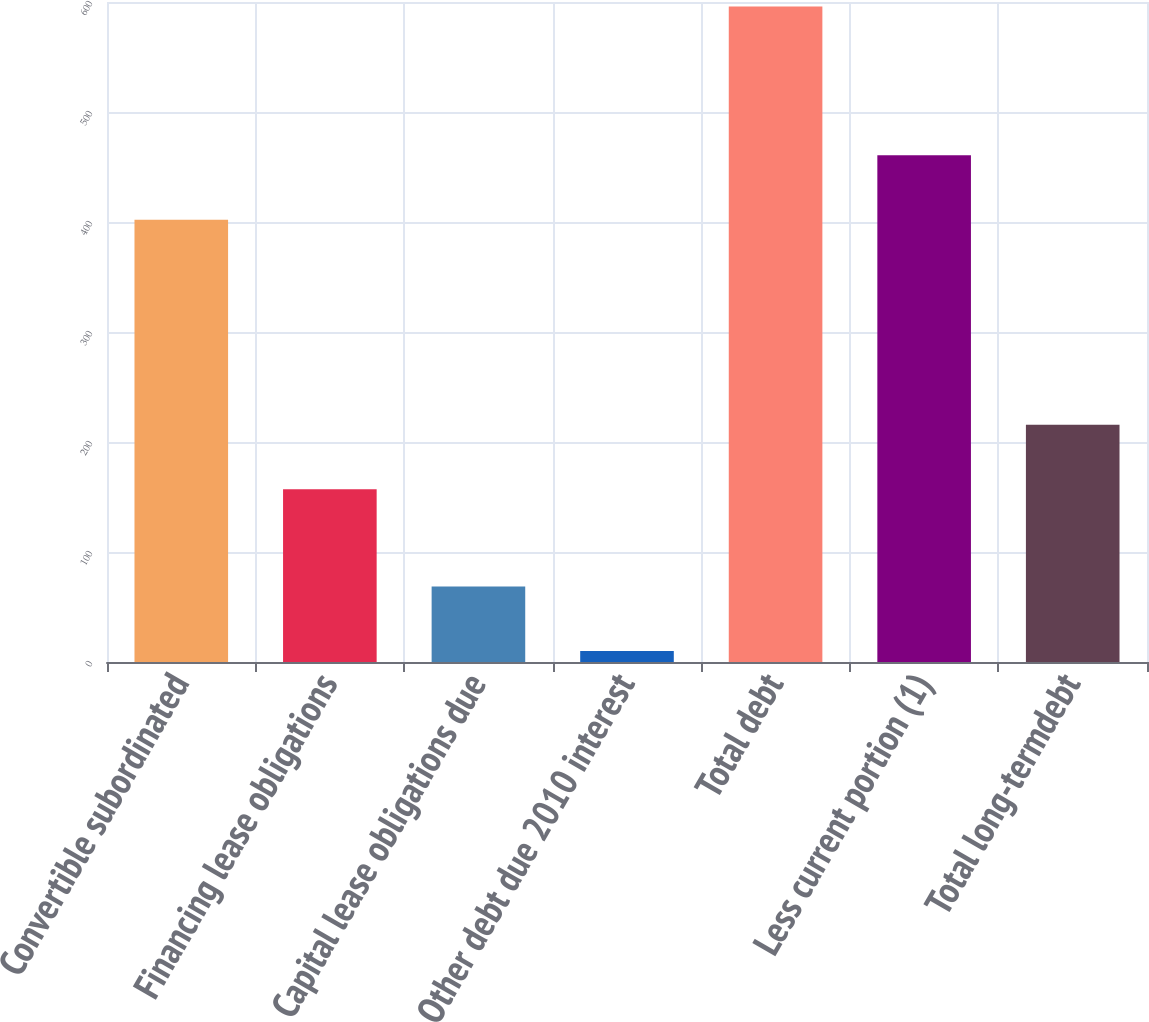Convert chart. <chart><loc_0><loc_0><loc_500><loc_500><bar_chart><fcel>Convertible subordinated<fcel>Financing lease obligations<fcel>Capital lease obligations due<fcel>Other debt due 2010 interest<fcel>Total debt<fcel>Less current portion (1)<fcel>Total long-termdebt<nl><fcel>402<fcel>157<fcel>68.6<fcel>10<fcel>596<fcel>460.6<fcel>215.6<nl></chart> 